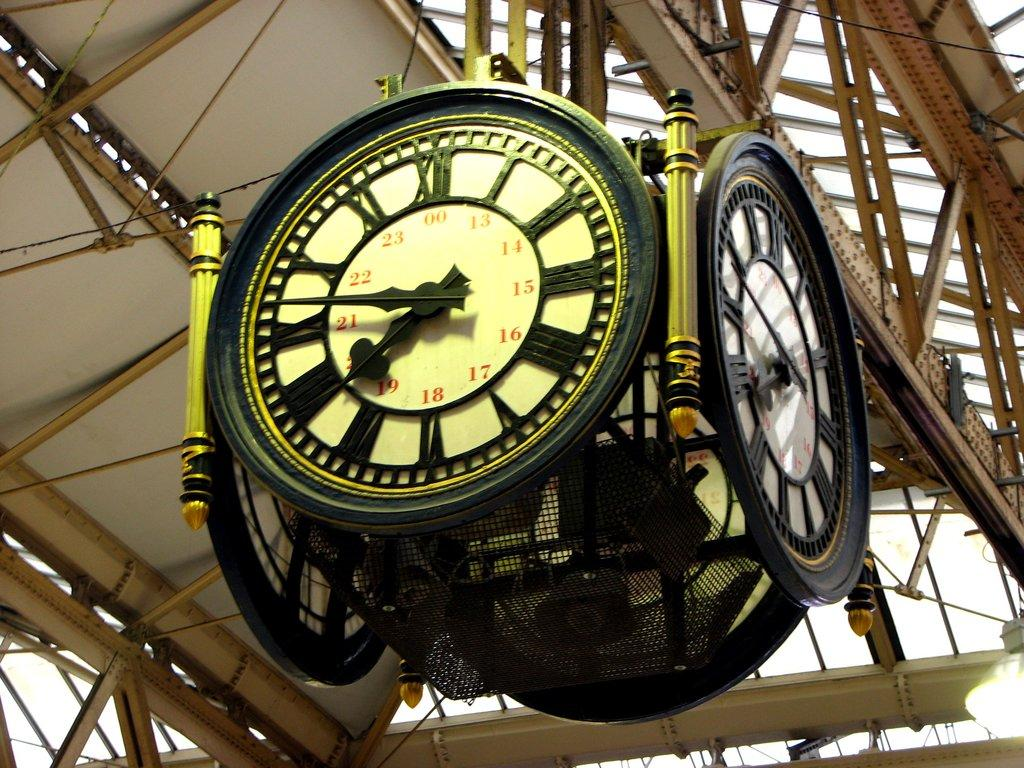Provide a one-sentence caption for the provided image. An analog 24 hour four faced clock hanging from the inside a building hanging from rafters. 